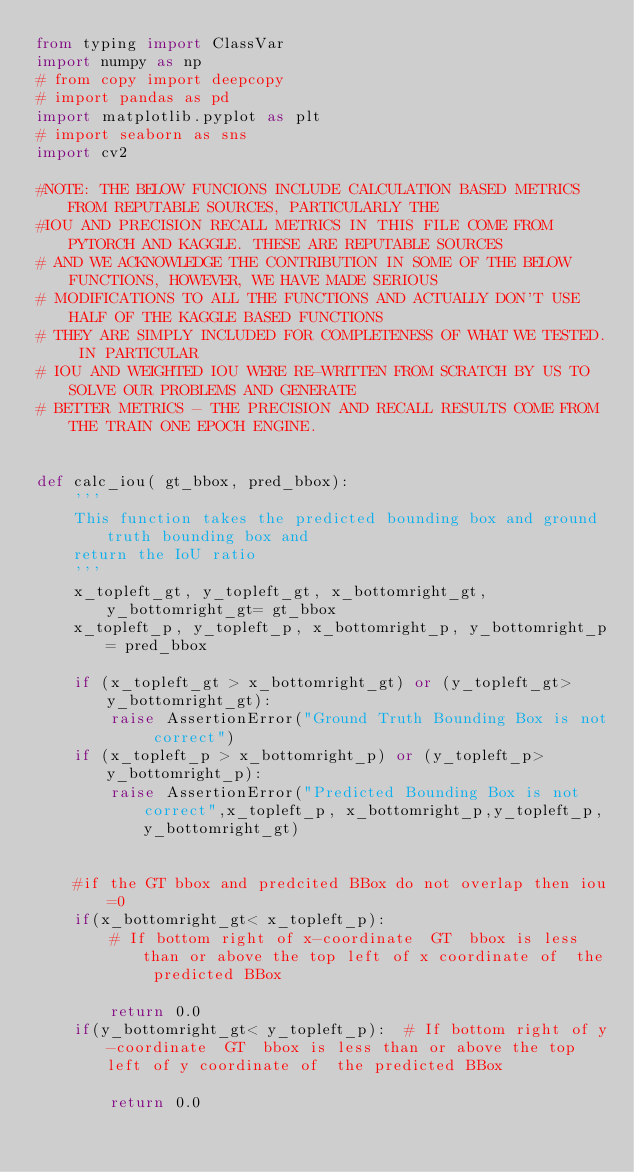Convert code to text. <code><loc_0><loc_0><loc_500><loc_500><_Python_>from typing import ClassVar
import numpy as np
# from copy import deepcopy
# import pandas as pd
import matplotlib.pyplot as plt
# import seaborn as sns
import cv2

#NOTE: THE BELOW FUNCIONS INCLUDE CALCULATION BASED METRICS FROM REPUTABLE SOURCES, PARTICULARLY THE
#IOU AND PRECISION RECALL METRICS IN THIS FILE COME FROM  PYTORCH AND KAGGLE. THESE ARE REPUTABLE SOURCES
# AND WE ACKNOWLEDGE THE CONTRIBUTION IN SOME OF THE BELOW FUNCTIONS, HOWEVER, WE HAVE MADE SERIOUS
# MODIFICATIONS TO ALL THE FUNCTIONS AND ACTUALLY DON'T USE HALF OF THE KAGGLE BASED FUNCTIONS
# THEY ARE SIMPLY INCLUDED FOR COMPLETENESS OF WHAT WE TESTED. IN PARTICULAR
# IOU AND WEIGHTED IOU WERE RE-WRITTEN FROM SCRATCH BY US TO SOLVE OUR PROBLEMS AND GENERATE
# BETTER METRICS - THE PRECISION AND RECALL RESULTS COME FROM THE TRAIN ONE EPOCH ENGINE.


def calc_iou( gt_bbox, pred_bbox):
    '''
    This function takes the predicted bounding box and ground truth bounding box and 
    return the IoU ratio
    '''
    x_topleft_gt, y_topleft_gt, x_bottomright_gt, y_bottomright_gt= gt_bbox
    x_topleft_p, y_topleft_p, x_bottomright_p, y_bottomright_p= pred_bbox
    
    if (x_topleft_gt > x_bottomright_gt) or (y_topleft_gt> y_bottomright_gt):
        raise AssertionError("Ground Truth Bounding Box is not correct")
    if (x_topleft_p > x_bottomright_p) or (y_topleft_p> y_bottomright_p):
        raise AssertionError("Predicted Bounding Box is not correct",x_topleft_p, x_bottomright_p,y_topleft_p,y_bottomright_gt)
        
         
    #if the GT bbox and predcited BBox do not overlap then iou=0
    if(x_bottomright_gt< x_topleft_p):
        # If bottom right of x-coordinate  GT  bbox is less than or above the top left of x coordinate of  the predicted BBox
        
        return 0.0
    if(y_bottomright_gt< y_topleft_p):  # If bottom right of y-coordinate  GT  bbox is less than or above the top left of y coordinate of  the predicted BBox
        
        return 0.0</code> 